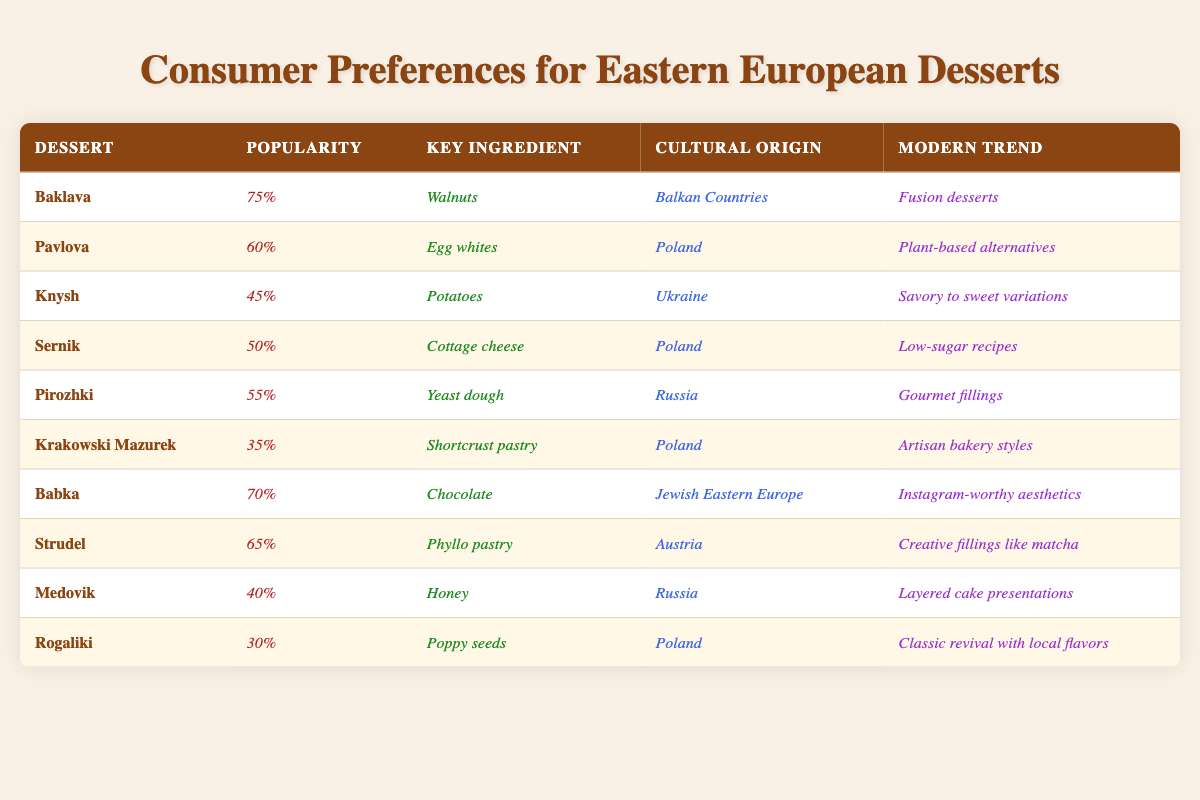What is the most popular Eastern European dessert according to the table? The table lists desserts along with their popularity percentages. By reviewing the percentages, "Baklava" has the highest value at 75%.
Answer: Baklava Which dessert has the lowest popularity percentage? The popularity percentages are listed for each dessert. "Rogaliki" has the lowest percentage at 30%.
Answer: Rogaliki What is the key ingredient of Babka? The table shows that the key ingredient listed for "Babka" is "Chocolate".
Answer: Chocolate How many desserts have popularity percentages above 60%? The desserts with popularity percentages above 60% are "Baklava" (75%), "Babka" (70%), and "Strudel" (65%). Adding these, there are three desserts in total above 60%.
Answer: 3 Does "Pavlova" have a key ingredient related to dairy? The key ingredient for "Pavlova" is "Egg whites", which is an animal product, thus it can be considered related to dairy.
Answer: Yes What is the modern trend associated with Knysh? According to the table, the modern trend for "Knysh" is "Savory to sweet variations".
Answer: Savory to sweet variations Which dessert has a cultural origin from Russia and what is its modern trend? The desserts from Russia listed are "Pirozhki" and "Medovik". "Pirozhki" follows the trend of "Gourmet fillings" and "Medovik" has a modern trend of "Layered cake presentations".
Answer: Pirozhki: Gourmet fillings; Medovik: Layered cake presentations Calculate the average popularity percentage of all the desserts listed in the table. To find the average, sum all the popularity percentages: 75 + 60 + 45 + 50 + 55 + 35 + 70 + 65 + 40 + 30 = 585. There are 10 desserts, so the average is 585 / 10 = 58.5.
Answer: 58.5 Is there any dessert from Poland that has a popularity percentage of 50% or more? The Polish desserts listed are "Pavlova" (60%), "Sernik" (50%), and "Krakowski Mazurek" (35%). Both "Pavlova" and "Sernik" meet the criterion of 50% or more in popularity.
Answer: Yes Which dessert(s) are associated with the modern trend of low-sugar recipes? From the table, "Sernik" is associated with the modern trend of "Low-sugar recipes". This is the only dessert with this trend.
Answer: Sernik Identify one dessert with a cultural origin from the Balkan countries and describe its modern trend. The dessert "Baklava" has a cultural origin from the Balkan countries and is associated with the modern trend of "Fusion desserts".
Answer: Baklava: Fusion desserts 